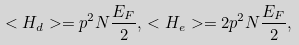<formula> <loc_0><loc_0><loc_500><loc_500>< H _ { d } > = p ^ { 2 } N \frac { E _ { F } } { 2 } , \, < H _ { e } > = 2 p ^ { 2 } N \frac { E _ { F } } { 2 } ,</formula> 